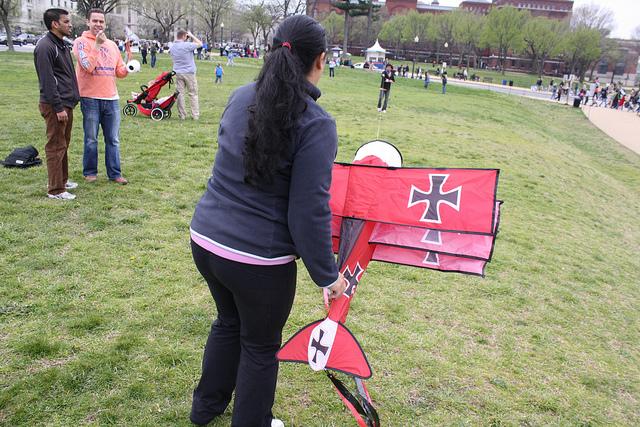What kind of kite does the lady have?
Write a very short answer. Plane. Is it a hot day out?
Short answer required. No. Is this outside?
Give a very brief answer. Yes. 